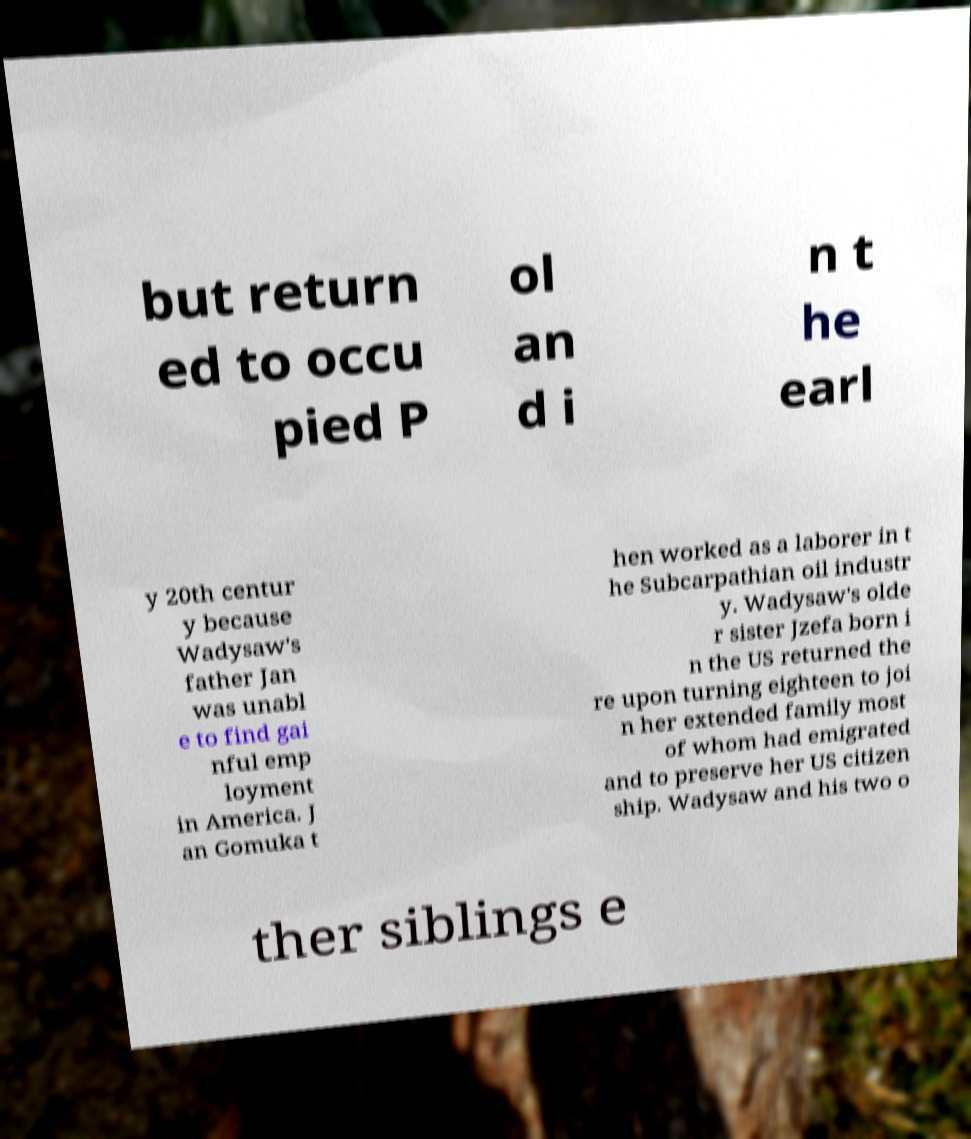Could you extract and type out the text from this image? but return ed to occu pied P ol an d i n t he earl y 20th centur y because Wadysaw's father Jan was unabl e to find gai nful emp loyment in America. J an Gomuka t hen worked as a laborer in t he Subcarpathian oil industr y. Wadysaw's olde r sister Jzefa born i n the US returned the re upon turning eighteen to joi n her extended family most of whom had emigrated and to preserve her US citizen ship. Wadysaw and his two o ther siblings e 